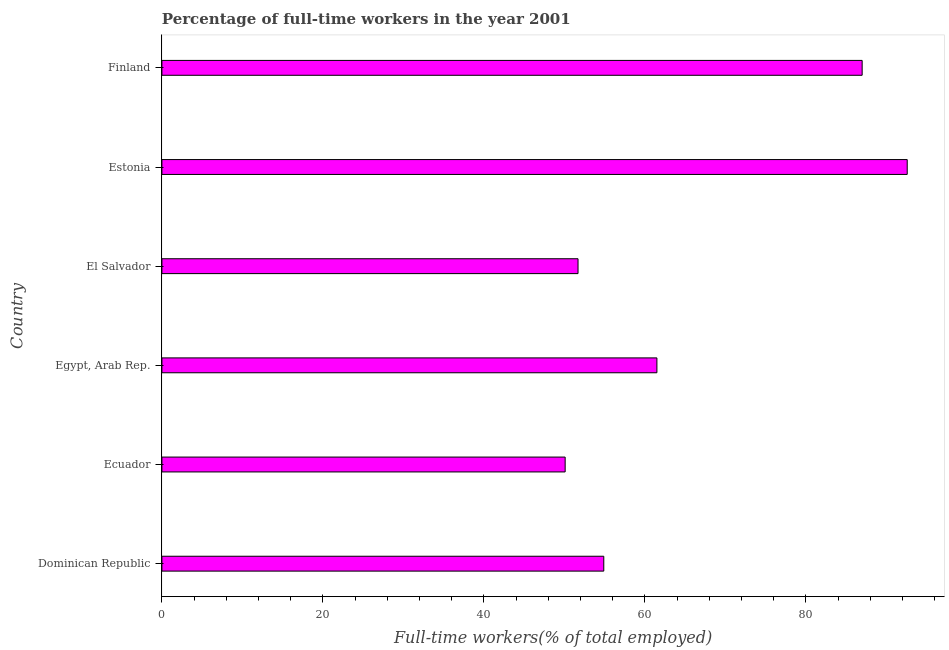Does the graph contain grids?
Provide a short and direct response. No. What is the title of the graph?
Your answer should be very brief. Percentage of full-time workers in the year 2001. What is the label or title of the X-axis?
Your response must be concise. Full-time workers(% of total employed). What is the percentage of full-time workers in Finland?
Provide a short and direct response. 87. Across all countries, what is the maximum percentage of full-time workers?
Keep it short and to the point. 92.6. Across all countries, what is the minimum percentage of full-time workers?
Provide a succinct answer. 50.1. In which country was the percentage of full-time workers maximum?
Keep it short and to the point. Estonia. In which country was the percentage of full-time workers minimum?
Ensure brevity in your answer.  Ecuador. What is the sum of the percentage of full-time workers?
Offer a terse response. 397.8. What is the difference between the percentage of full-time workers in El Salvador and Estonia?
Make the answer very short. -40.9. What is the average percentage of full-time workers per country?
Make the answer very short. 66.3. What is the median percentage of full-time workers?
Make the answer very short. 58.2. In how many countries, is the percentage of full-time workers greater than 48 %?
Make the answer very short. 6. What is the ratio of the percentage of full-time workers in Egypt, Arab Rep. to that in Finland?
Your response must be concise. 0.71. What is the difference between the highest and the second highest percentage of full-time workers?
Provide a short and direct response. 5.6. Is the sum of the percentage of full-time workers in Estonia and Finland greater than the maximum percentage of full-time workers across all countries?
Your answer should be compact. Yes. What is the difference between the highest and the lowest percentage of full-time workers?
Keep it short and to the point. 42.5. Are all the bars in the graph horizontal?
Provide a succinct answer. Yes. Are the values on the major ticks of X-axis written in scientific E-notation?
Your response must be concise. No. What is the Full-time workers(% of total employed) in Dominican Republic?
Keep it short and to the point. 54.9. What is the Full-time workers(% of total employed) of Ecuador?
Provide a succinct answer. 50.1. What is the Full-time workers(% of total employed) of Egypt, Arab Rep.?
Keep it short and to the point. 61.5. What is the Full-time workers(% of total employed) in El Salvador?
Give a very brief answer. 51.7. What is the Full-time workers(% of total employed) in Estonia?
Make the answer very short. 92.6. What is the Full-time workers(% of total employed) of Finland?
Provide a short and direct response. 87. What is the difference between the Full-time workers(% of total employed) in Dominican Republic and Estonia?
Your answer should be compact. -37.7. What is the difference between the Full-time workers(% of total employed) in Dominican Republic and Finland?
Make the answer very short. -32.1. What is the difference between the Full-time workers(% of total employed) in Ecuador and Egypt, Arab Rep.?
Your answer should be compact. -11.4. What is the difference between the Full-time workers(% of total employed) in Ecuador and El Salvador?
Ensure brevity in your answer.  -1.6. What is the difference between the Full-time workers(% of total employed) in Ecuador and Estonia?
Make the answer very short. -42.5. What is the difference between the Full-time workers(% of total employed) in Ecuador and Finland?
Keep it short and to the point. -36.9. What is the difference between the Full-time workers(% of total employed) in Egypt, Arab Rep. and El Salvador?
Provide a succinct answer. 9.8. What is the difference between the Full-time workers(% of total employed) in Egypt, Arab Rep. and Estonia?
Provide a succinct answer. -31.1. What is the difference between the Full-time workers(% of total employed) in Egypt, Arab Rep. and Finland?
Your answer should be compact. -25.5. What is the difference between the Full-time workers(% of total employed) in El Salvador and Estonia?
Offer a terse response. -40.9. What is the difference between the Full-time workers(% of total employed) in El Salvador and Finland?
Offer a terse response. -35.3. What is the ratio of the Full-time workers(% of total employed) in Dominican Republic to that in Ecuador?
Your response must be concise. 1.1. What is the ratio of the Full-time workers(% of total employed) in Dominican Republic to that in Egypt, Arab Rep.?
Offer a terse response. 0.89. What is the ratio of the Full-time workers(% of total employed) in Dominican Republic to that in El Salvador?
Keep it short and to the point. 1.06. What is the ratio of the Full-time workers(% of total employed) in Dominican Republic to that in Estonia?
Offer a terse response. 0.59. What is the ratio of the Full-time workers(% of total employed) in Dominican Republic to that in Finland?
Your answer should be very brief. 0.63. What is the ratio of the Full-time workers(% of total employed) in Ecuador to that in Egypt, Arab Rep.?
Offer a very short reply. 0.81. What is the ratio of the Full-time workers(% of total employed) in Ecuador to that in Estonia?
Give a very brief answer. 0.54. What is the ratio of the Full-time workers(% of total employed) in Ecuador to that in Finland?
Give a very brief answer. 0.58. What is the ratio of the Full-time workers(% of total employed) in Egypt, Arab Rep. to that in El Salvador?
Your answer should be very brief. 1.19. What is the ratio of the Full-time workers(% of total employed) in Egypt, Arab Rep. to that in Estonia?
Make the answer very short. 0.66. What is the ratio of the Full-time workers(% of total employed) in Egypt, Arab Rep. to that in Finland?
Offer a terse response. 0.71. What is the ratio of the Full-time workers(% of total employed) in El Salvador to that in Estonia?
Provide a succinct answer. 0.56. What is the ratio of the Full-time workers(% of total employed) in El Salvador to that in Finland?
Provide a succinct answer. 0.59. What is the ratio of the Full-time workers(% of total employed) in Estonia to that in Finland?
Your answer should be very brief. 1.06. 